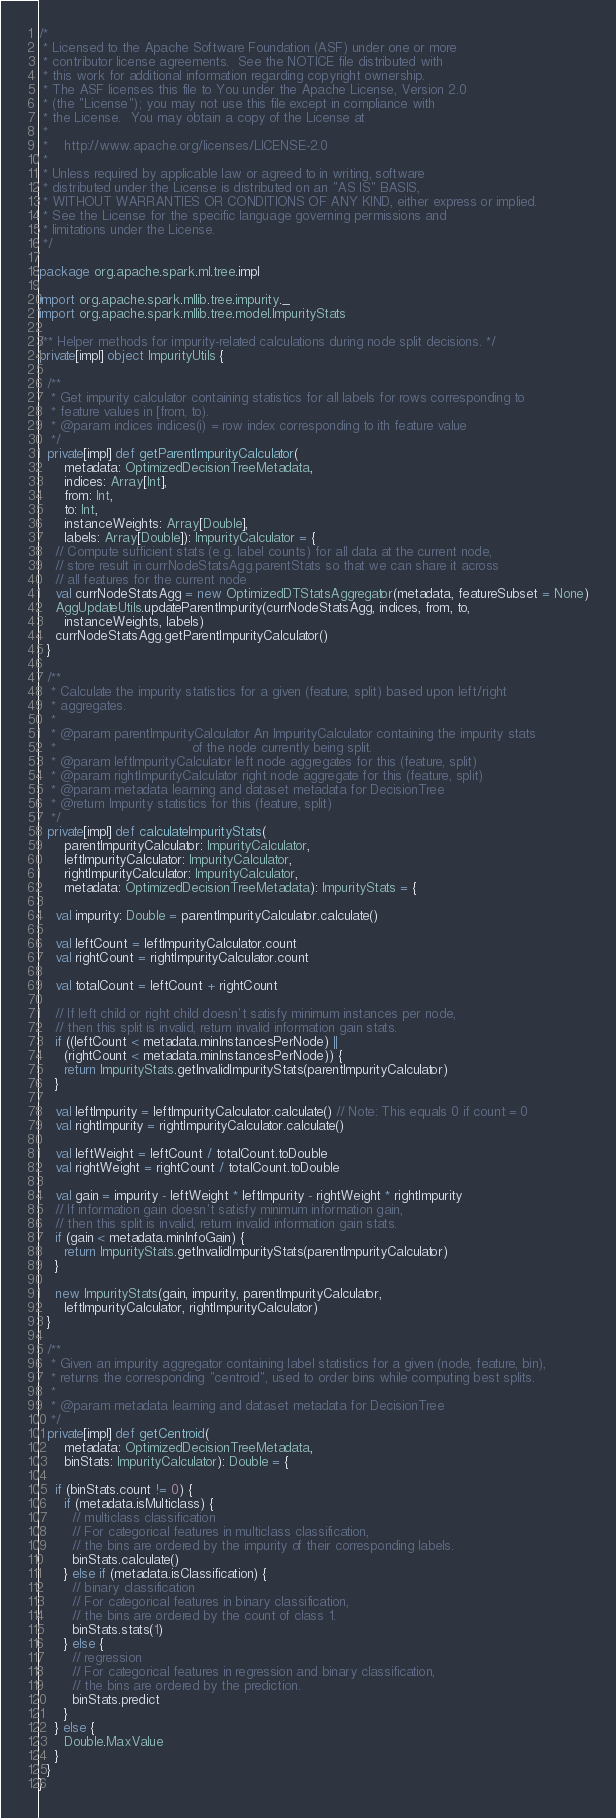<code> <loc_0><loc_0><loc_500><loc_500><_Scala_>/*
 * Licensed to the Apache Software Foundation (ASF) under one or more
 * contributor license agreements.  See the NOTICE file distributed with
 * this work for additional information regarding copyright ownership.
 * The ASF licenses this file to You under the Apache License, Version 2.0
 * (the "License"); you may not use this file except in compliance with
 * the License.  You may obtain a copy of the License at
 *
 *    http://www.apache.org/licenses/LICENSE-2.0
 *
 * Unless required by applicable law or agreed to in writing, software
 * distributed under the License is distributed on an "AS IS" BASIS,
 * WITHOUT WARRANTIES OR CONDITIONS OF ANY KIND, either express or implied.
 * See the License for the specific language governing permissions and
 * limitations under the License.
 */

package org.apache.spark.ml.tree.impl

import org.apache.spark.mllib.tree.impurity._
import org.apache.spark.mllib.tree.model.ImpurityStats

/** Helper methods for impurity-related calculations during node split decisions. */
private[impl] object ImpurityUtils {

  /**
   * Get impurity calculator containing statistics for all labels for rows corresponding to
   * feature values in [from, to).
   * @param indices indices(i) = row index corresponding to ith feature value
   */
  private[impl] def getParentImpurityCalculator(
      metadata: OptimizedDecisionTreeMetadata,
      indices: Array[Int],
      from: Int,
      to: Int,
      instanceWeights: Array[Double],
      labels: Array[Double]): ImpurityCalculator = {
    // Compute sufficient stats (e.g. label counts) for all data at the current node,
    // store result in currNodeStatsAgg.parentStats so that we can share it across
    // all features for the current node
    val currNodeStatsAgg = new OptimizedDTStatsAggregator(metadata, featureSubset = None)
    AggUpdateUtils.updateParentImpurity(currNodeStatsAgg, indices, from, to,
      instanceWeights, labels)
    currNodeStatsAgg.getParentImpurityCalculator()
  }

  /**
   * Calculate the impurity statistics for a given (feature, split) based upon left/right
   * aggregates.
   *
   * @param parentImpurityCalculator An ImpurityCalculator containing the impurity stats
   *                                 of the node currently being split.
   * @param leftImpurityCalculator left node aggregates for this (feature, split)
   * @param rightImpurityCalculator right node aggregate for this (feature, split)
   * @param metadata learning and dataset metadata for DecisionTree
   * @return Impurity statistics for this (feature, split)
   */
  private[impl] def calculateImpurityStats(
      parentImpurityCalculator: ImpurityCalculator,
      leftImpurityCalculator: ImpurityCalculator,
      rightImpurityCalculator: ImpurityCalculator,
      metadata: OptimizedDecisionTreeMetadata): ImpurityStats = {

    val impurity: Double = parentImpurityCalculator.calculate()

    val leftCount = leftImpurityCalculator.count
    val rightCount = rightImpurityCalculator.count

    val totalCount = leftCount + rightCount

    // If left child or right child doesn't satisfy minimum instances per node,
    // then this split is invalid, return invalid information gain stats.
    if ((leftCount < metadata.minInstancesPerNode) ||
      (rightCount < metadata.minInstancesPerNode)) {
      return ImpurityStats.getInvalidImpurityStats(parentImpurityCalculator)
    }

    val leftImpurity = leftImpurityCalculator.calculate() // Note: This equals 0 if count = 0
    val rightImpurity = rightImpurityCalculator.calculate()

    val leftWeight = leftCount / totalCount.toDouble
    val rightWeight = rightCount / totalCount.toDouble

    val gain = impurity - leftWeight * leftImpurity - rightWeight * rightImpurity
    // If information gain doesn't satisfy minimum information gain,
    // then this split is invalid, return invalid information gain stats.
    if (gain < metadata.minInfoGain) {
      return ImpurityStats.getInvalidImpurityStats(parentImpurityCalculator)
    }

    new ImpurityStats(gain, impurity, parentImpurityCalculator,
      leftImpurityCalculator, rightImpurityCalculator)
  }

  /**
   * Given an impurity aggregator containing label statistics for a given (node, feature, bin),
   * returns the corresponding "centroid", used to order bins while computing best splits.
   *
   * @param metadata learning and dataset metadata for DecisionTree
   */
  private[impl] def getCentroid(
      metadata: OptimizedDecisionTreeMetadata,
      binStats: ImpurityCalculator): Double = {

    if (binStats.count != 0) {
      if (metadata.isMulticlass) {
        // multiclass classification
        // For categorical features in multiclass classification,
        // the bins are ordered by the impurity of their corresponding labels.
        binStats.calculate()
      } else if (metadata.isClassification) {
        // binary classification
        // For categorical features in binary classification,
        // the bins are ordered by the count of class 1.
        binStats.stats(1)
      } else {
        // regression
        // For categorical features in regression and binary classification,
        // the bins are ordered by the prediction.
        binStats.predict
      }
    } else {
      Double.MaxValue
    }
  }
}
</code> 